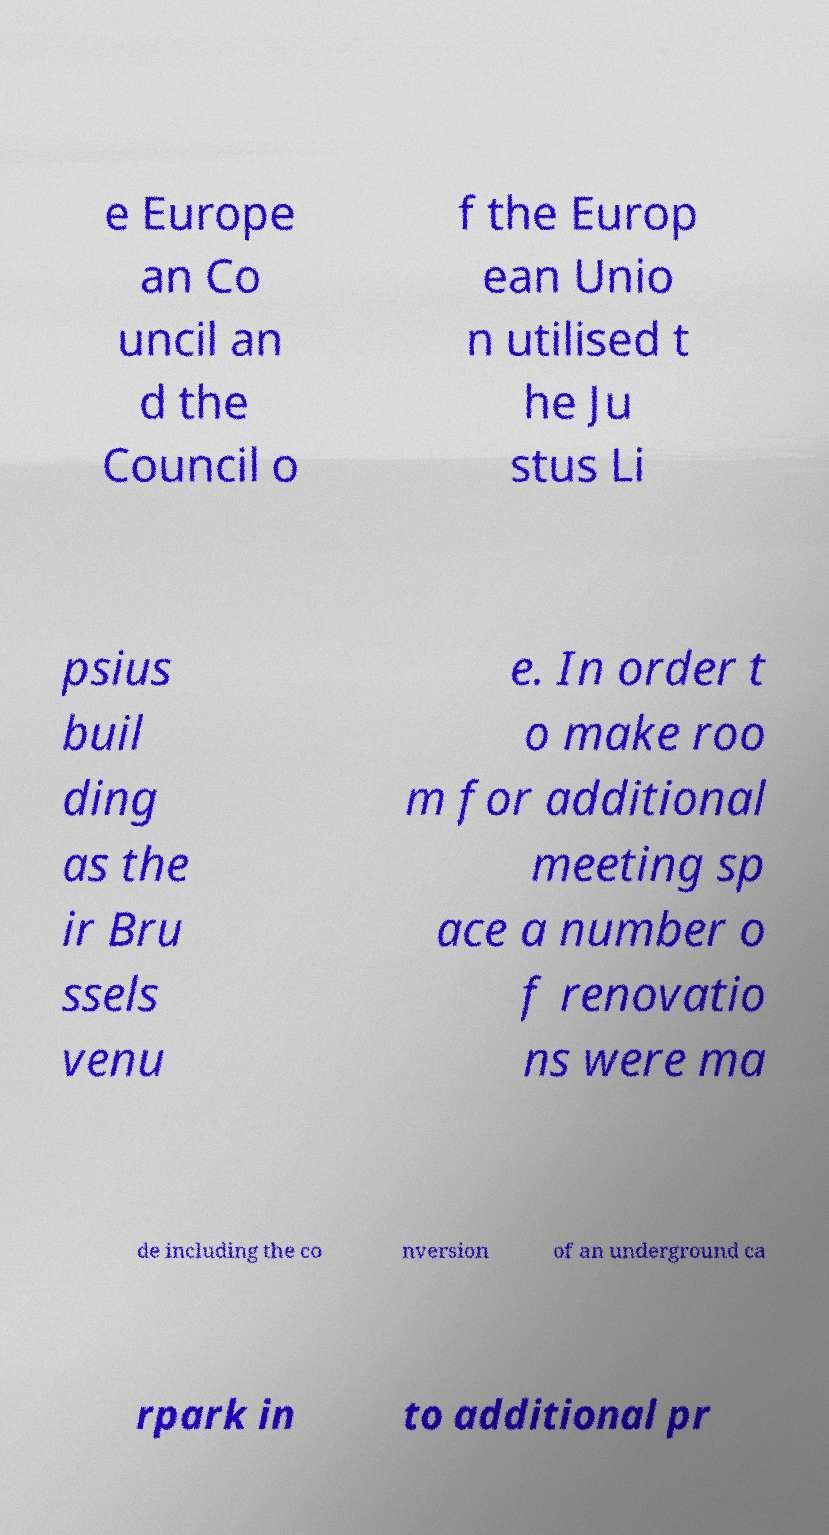Please read and relay the text visible in this image. What does it say? e Europe an Co uncil an d the Council o f the Europ ean Unio n utilised t he Ju stus Li psius buil ding as the ir Bru ssels venu e. In order t o make roo m for additional meeting sp ace a number o f renovatio ns were ma de including the co nversion of an underground ca rpark in to additional pr 